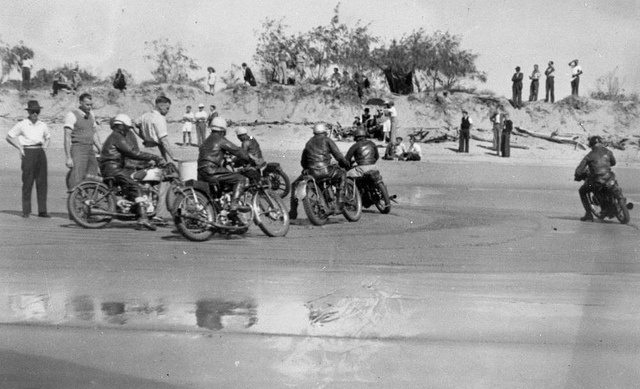Describe the objects in this image and their specific colors. I can see people in lightgray, darkgray, gray, and black tones, motorcycle in lightgray, gray, black, and darkgray tones, motorcycle in lightgray, gray, and black tones, people in lightgray, black, gray, gainsboro, and darkgray tones, and people in lightgray, black, gray, and darkgray tones in this image. 